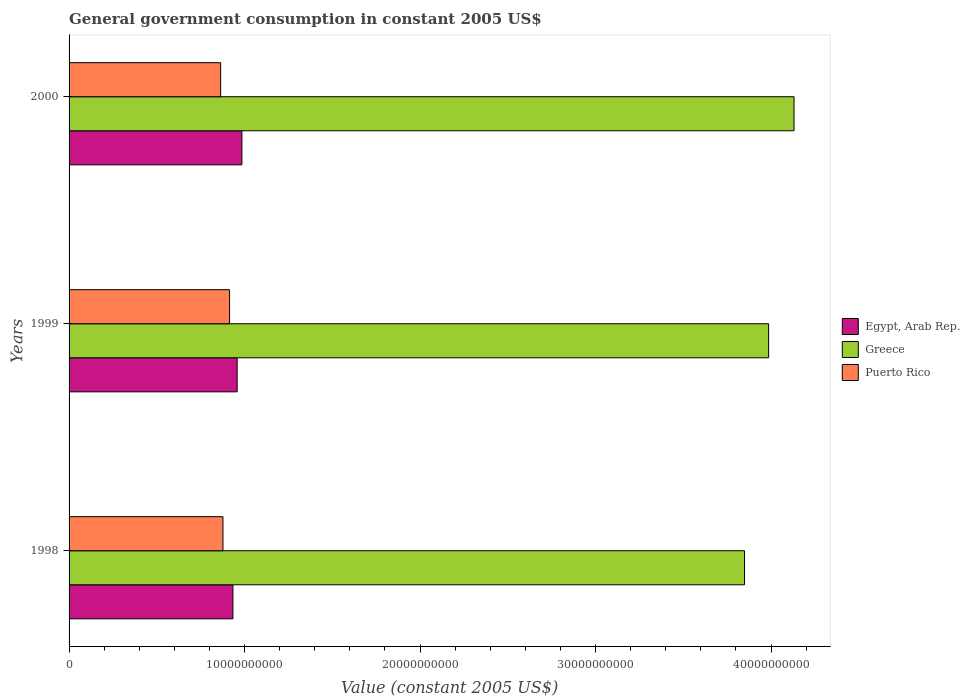How many different coloured bars are there?
Keep it short and to the point. 3. Are the number of bars on each tick of the Y-axis equal?
Your answer should be compact. Yes. How many bars are there on the 3rd tick from the top?
Give a very brief answer. 3. How many bars are there on the 1st tick from the bottom?
Offer a very short reply. 3. What is the label of the 1st group of bars from the top?
Offer a very short reply. 2000. In how many cases, is the number of bars for a given year not equal to the number of legend labels?
Your response must be concise. 0. What is the government conusmption in Puerto Rico in 1999?
Provide a succinct answer. 9.15e+09. Across all years, what is the maximum government conusmption in Puerto Rico?
Your response must be concise. 9.15e+09. Across all years, what is the minimum government conusmption in Egypt, Arab Rep.?
Your answer should be very brief. 9.34e+09. In which year was the government conusmption in Puerto Rico minimum?
Keep it short and to the point. 2000. What is the total government conusmption in Puerto Rico in the graph?
Offer a terse response. 2.66e+1. What is the difference between the government conusmption in Puerto Rico in 1998 and that in 1999?
Provide a short and direct response. -3.78e+08. What is the difference between the government conusmption in Egypt, Arab Rep. in 2000 and the government conusmption in Puerto Rico in 1998?
Ensure brevity in your answer.  1.08e+09. What is the average government conusmption in Greece per year?
Make the answer very short. 3.99e+1. In the year 1999, what is the difference between the government conusmption in Egypt, Arab Rep. and government conusmption in Greece?
Make the answer very short. -3.03e+1. In how many years, is the government conusmption in Greece greater than 8000000000 US$?
Your answer should be compact. 3. What is the ratio of the government conusmption in Egypt, Arab Rep. in 1999 to that in 2000?
Offer a very short reply. 0.97. Is the government conusmption in Greece in 1998 less than that in 1999?
Your answer should be very brief. Yes. Is the difference between the government conusmption in Egypt, Arab Rep. in 1999 and 2000 greater than the difference between the government conusmption in Greece in 1999 and 2000?
Make the answer very short. Yes. What is the difference between the highest and the second highest government conusmption in Egypt, Arab Rep.?
Your answer should be very brief. 2.71e+08. What is the difference between the highest and the lowest government conusmption in Puerto Rico?
Ensure brevity in your answer.  5.09e+08. What does the 3rd bar from the top in 1999 represents?
Your response must be concise. Egypt, Arab Rep. What does the 3rd bar from the bottom in 1999 represents?
Your response must be concise. Puerto Rico. Is it the case that in every year, the sum of the government conusmption in Puerto Rico and government conusmption in Greece is greater than the government conusmption in Egypt, Arab Rep.?
Your answer should be very brief. Yes. Are all the bars in the graph horizontal?
Keep it short and to the point. Yes. How many legend labels are there?
Your answer should be very brief. 3. How are the legend labels stacked?
Make the answer very short. Vertical. What is the title of the graph?
Offer a terse response. General government consumption in constant 2005 US$. Does "Trinidad and Tobago" appear as one of the legend labels in the graph?
Provide a short and direct response. No. What is the label or title of the X-axis?
Offer a terse response. Value (constant 2005 US$). What is the label or title of the Y-axis?
Make the answer very short. Years. What is the Value (constant 2005 US$) in Egypt, Arab Rep. in 1998?
Keep it short and to the point. 9.34e+09. What is the Value (constant 2005 US$) in Greece in 1998?
Your answer should be compact. 3.85e+1. What is the Value (constant 2005 US$) in Puerto Rico in 1998?
Provide a succinct answer. 8.77e+09. What is the Value (constant 2005 US$) of Egypt, Arab Rep. in 1999?
Your answer should be compact. 9.58e+09. What is the Value (constant 2005 US$) of Greece in 1999?
Provide a succinct answer. 3.99e+1. What is the Value (constant 2005 US$) of Puerto Rico in 1999?
Offer a terse response. 9.15e+09. What is the Value (constant 2005 US$) in Egypt, Arab Rep. in 2000?
Give a very brief answer. 9.85e+09. What is the Value (constant 2005 US$) in Greece in 2000?
Offer a terse response. 4.13e+1. What is the Value (constant 2005 US$) of Puerto Rico in 2000?
Ensure brevity in your answer.  8.64e+09. Across all years, what is the maximum Value (constant 2005 US$) of Egypt, Arab Rep.?
Your response must be concise. 9.85e+09. Across all years, what is the maximum Value (constant 2005 US$) of Greece?
Give a very brief answer. 4.13e+1. Across all years, what is the maximum Value (constant 2005 US$) of Puerto Rico?
Your answer should be compact. 9.15e+09. Across all years, what is the minimum Value (constant 2005 US$) of Egypt, Arab Rep.?
Offer a very short reply. 9.34e+09. Across all years, what is the minimum Value (constant 2005 US$) in Greece?
Offer a terse response. 3.85e+1. Across all years, what is the minimum Value (constant 2005 US$) of Puerto Rico?
Your response must be concise. 8.64e+09. What is the total Value (constant 2005 US$) in Egypt, Arab Rep. in the graph?
Provide a succinct answer. 2.88e+1. What is the total Value (constant 2005 US$) of Greece in the graph?
Keep it short and to the point. 1.20e+11. What is the total Value (constant 2005 US$) of Puerto Rico in the graph?
Give a very brief answer. 2.66e+1. What is the difference between the Value (constant 2005 US$) of Egypt, Arab Rep. in 1998 and that in 1999?
Offer a terse response. -2.41e+08. What is the difference between the Value (constant 2005 US$) of Greece in 1998 and that in 1999?
Keep it short and to the point. -1.37e+09. What is the difference between the Value (constant 2005 US$) in Puerto Rico in 1998 and that in 1999?
Give a very brief answer. -3.78e+08. What is the difference between the Value (constant 2005 US$) in Egypt, Arab Rep. in 1998 and that in 2000?
Keep it short and to the point. -5.12e+08. What is the difference between the Value (constant 2005 US$) of Greece in 1998 and that in 2000?
Your response must be concise. -2.82e+09. What is the difference between the Value (constant 2005 US$) of Puerto Rico in 1998 and that in 2000?
Offer a very short reply. 1.31e+08. What is the difference between the Value (constant 2005 US$) in Egypt, Arab Rep. in 1999 and that in 2000?
Ensure brevity in your answer.  -2.71e+08. What is the difference between the Value (constant 2005 US$) of Greece in 1999 and that in 2000?
Provide a succinct answer. -1.45e+09. What is the difference between the Value (constant 2005 US$) of Puerto Rico in 1999 and that in 2000?
Provide a short and direct response. 5.09e+08. What is the difference between the Value (constant 2005 US$) of Egypt, Arab Rep. in 1998 and the Value (constant 2005 US$) of Greece in 1999?
Give a very brief answer. -3.05e+1. What is the difference between the Value (constant 2005 US$) of Egypt, Arab Rep. in 1998 and the Value (constant 2005 US$) of Puerto Rico in 1999?
Ensure brevity in your answer.  1.91e+08. What is the difference between the Value (constant 2005 US$) of Greece in 1998 and the Value (constant 2005 US$) of Puerto Rico in 1999?
Offer a terse response. 2.93e+1. What is the difference between the Value (constant 2005 US$) of Egypt, Arab Rep. in 1998 and the Value (constant 2005 US$) of Greece in 2000?
Make the answer very short. -3.20e+1. What is the difference between the Value (constant 2005 US$) of Egypt, Arab Rep. in 1998 and the Value (constant 2005 US$) of Puerto Rico in 2000?
Ensure brevity in your answer.  7.00e+08. What is the difference between the Value (constant 2005 US$) in Greece in 1998 and the Value (constant 2005 US$) in Puerto Rico in 2000?
Keep it short and to the point. 2.99e+1. What is the difference between the Value (constant 2005 US$) in Egypt, Arab Rep. in 1999 and the Value (constant 2005 US$) in Greece in 2000?
Ensure brevity in your answer.  -3.17e+1. What is the difference between the Value (constant 2005 US$) of Egypt, Arab Rep. in 1999 and the Value (constant 2005 US$) of Puerto Rico in 2000?
Provide a succinct answer. 9.41e+08. What is the difference between the Value (constant 2005 US$) in Greece in 1999 and the Value (constant 2005 US$) in Puerto Rico in 2000?
Provide a short and direct response. 3.12e+1. What is the average Value (constant 2005 US$) of Egypt, Arab Rep. per year?
Offer a terse response. 9.59e+09. What is the average Value (constant 2005 US$) of Greece per year?
Ensure brevity in your answer.  3.99e+1. What is the average Value (constant 2005 US$) of Puerto Rico per year?
Provide a succinct answer. 8.85e+09. In the year 1998, what is the difference between the Value (constant 2005 US$) in Egypt, Arab Rep. and Value (constant 2005 US$) in Greece?
Your answer should be compact. -2.92e+1. In the year 1998, what is the difference between the Value (constant 2005 US$) in Egypt, Arab Rep. and Value (constant 2005 US$) in Puerto Rico?
Provide a short and direct response. 5.69e+08. In the year 1998, what is the difference between the Value (constant 2005 US$) of Greece and Value (constant 2005 US$) of Puerto Rico?
Provide a short and direct response. 2.97e+1. In the year 1999, what is the difference between the Value (constant 2005 US$) of Egypt, Arab Rep. and Value (constant 2005 US$) of Greece?
Your answer should be compact. -3.03e+1. In the year 1999, what is the difference between the Value (constant 2005 US$) in Egypt, Arab Rep. and Value (constant 2005 US$) in Puerto Rico?
Your answer should be compact. 4.31e+08. In the year 1999, what is the difference between the Value (constant 2005 US$) in Greece and Value (constant 2005 US$) in Puerto Rico?
Your answer should be very brief. 3.07e+1. In the year 2000, what is the difference between the Value (constant 2005 US$) of Egypt, Arab Rep. and Value (constant 2005 US$) of Greece?
Give a very brief answer. -3.15e+1. In the year 2000, what is the difference between the Value (constant 2005 US$) in Egypt, Arab Rep. and Value (constant 2005 US$) in Puerto Rico?
Your response must be concise. 1.21e+09. In the year 2000, what is the difference between the Value (constant 2005 US$) of Greece and Value (constant 2005 US$) of Puerto Rico?
Your response must be concise. 3.27e+1. What is the ratio of the Value (constant 2005 US$) in Egypt, Arab Rep. in 1998 to that in 1999?
Ensure brevity in your answer.  0.97. What is the ratio of the Value (constant 2005 US$) of Greece in 1998 to that in 1999?
Provide a short and direct response. 0.97. What is the ratio of the Value (constant 2005 US$) of Puerto Rico in 1998 to that in 1999?
Offer a terse response. 0.96. What is the ratio of the Value (constant 2005 US$) of Egypt, Arab Rep. in 1998 to that in 2000?
Your response must be concise. 0.95. What is the ratio of the Value (constant 2005 US$) in Greece in 1998 to that in 2000?
Give a very brief answer. 0.93. What is the ratio of the Value (constant 2005 US$) of Puerto Rico in 1998 to that in 2000?
Your answer should be very brief. 1.02. What is the ratio of the Value (constant 2005 US$) in Egypt, Arab Rep. in 1999 to that in 2000?
Offer a very short reply. 0.97. What is the ratio of the Value (constant 2005 US$) of Greece in 1999 to that in 2000?
Make the answer very short. 0.96. What is the ratio of the Value (constant 2005 US$) of Puerto Rico in 1999 to that in 2000?
Your answer should be very brief. 1.06. What is the difference between the highest and the second highest Value (constant 2005 US$) of Egypt, Arab Rep.?
Provide a short and direct response. 2.71e+08. What is the difference between the highest and the second highest Value (constant 2005 US$) in Greece?
Ensure brevity in your answer.  1.45e+09. What is the difference between the highest and the second highest Value (constant 2005 US$) in Puerto Rico?
Keep it short and to the point. 3.78e+08. What is the difference between the highest and the lowest Value (constant 2005 US$) of Egypt, Arab Rep.?
Offer a very short reply. 5.12e+08. What is the difference between the highest and the lowest Value (constant 2005 US$) in Greece?
Give a very brief answer. 2.82e+09. What is the difference between the highest and the lowest Value (constant 2005 US$) in Puerto Rico?
Provide a short and direct response. 5.09e+08. 